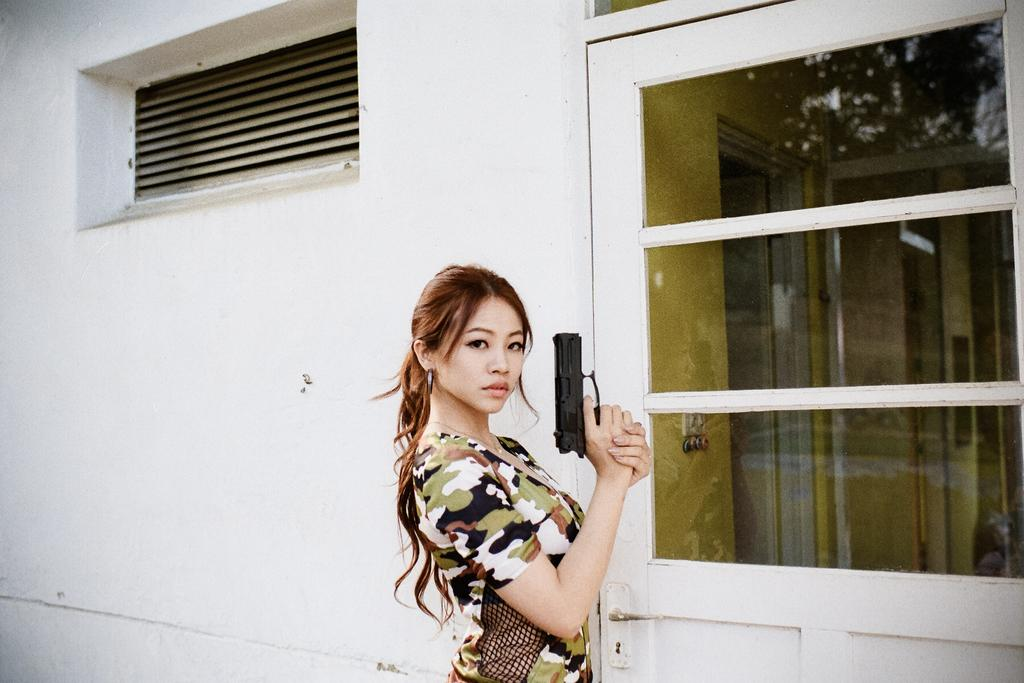What is the lady in the image holding? The lady is holding a gun in the image. What is the lady's posture in the image? The lady is standing in the image. What structure can be seen in the background of the image? There is a building in the image. What features does the building have? The building has a door and ventilation. What type of substance is the lady using to hold the gun in the image? The lady is not using any substance to hold the gun in the image; she is simply holding it with her hand. 